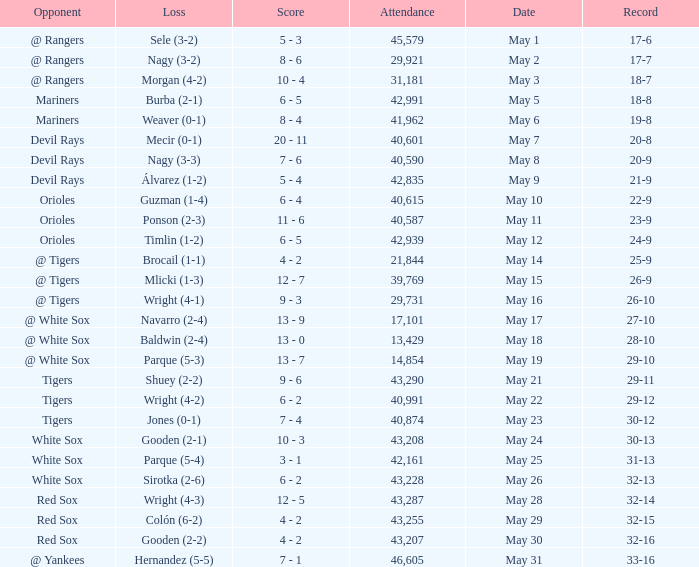Help me parse the entirety of this table. {'header': ['Opponent', 'Loss', 'Score', 'Attendance', 'Date', 'Record'], 'rows': [['@ Rangers', 'Sele (3-2)', '5 - 3', '45,579', 'May 1', '17-6'], ['@ Rangers', 'Nagy (3-2)', '8 - 6', '29,921', 'May 2', '17-7'], ['@ Rangers', 'Morgan (4-2)', '10 - 4', '31,181', 'May 3', '18-7'], ['Mariners', 'Burba (2-1)', '6 - 5', '42,991', 'May 5', '18-8'], ['Mariners', 'Weaver (0-1)', '8 - 4', '41,962', 'May 6', '19-8'], ['Devil Rays', 'Mecir (0-1)', '20 - 11', '40,601', 'May 7', '20-8'], ['Devil Rays', 'Nagy (3-3)', '7 - 6', '40,590', 'May 8', '20-9'], ['Devil Rays', 'Álvarez (1-2)', '5 - 4', '42,835', 'May 9', '21-9'], ['Orioles', 'Guzman (1-4)', '6 - 4', '40,615', 'May 10', '22-9'], ['Orioles', 'Ponson (2-3)', '11 - 6', '40,587', 'May 11', '23-9'], ['Orioles', 'Timlin (1-2)', '6 - 5', '42,939', 'May 12', '24-9'], ['@ Tigers', 'Brocail (1-1)', '4 - 2', '21,844', 'May 14', '25-9'], ['@ Tigers', 'Mlicki (1-3)', '12 - 7', '39,769', 'May 15', '26-9'], ['@ Tigers', 'Wright (4-1)', '9 - 3', '29,731', 'May 16', '26-10'], ['@ White Sox', 'Navarro (2-4)', '13 - 9', '17,101', 'May 17', '27-10'], ['@ White Sox', 'Baldwin (2-4)', '13 - 0', '13,429', 'May 18', '28-10'], ['@ White Sox', 'Parque (5-3)', '13 - 7', '14,854', 'May 19', '29-10'], ['Tigers', 'Shuey (2-2)', '9 - 6', '43,290', 'May 21', '29-11'], ['Tigers', 'Wright (4-2)', '6 - 2', '40,991', 'May 22', '29-12'], ['Tigers', 'Jones (0-1)', '7 - 4', '40,874', 'May 23', '30-12'], ['White Sox', 'Gooden (2-1)', '10 - 3', '43,208', 'May 24', '30-13'], ['White Sox', 'Parque (5-4)', '3 - 1', '42,161', 'May 25', '31-13'], ['White Sox', 'Sirotka (2-6)', '6 - 2', '43,228', 'May 26', '32-13'], ['Red Sox', 'Wright (4-3)', '12 - 5', '43,287', 'May 28', '32-14'], ['Red Sox', 'Colón (6-2)', '4 - 2', '43,255', 'May 29', '32-15'], ['Red Sox', 'Gooden (2-2)', '4 - 2', '43,207', 'May 30', '32-16'], ['@ Yankees', 'Hernandez (5-5)', '7 - 1', '46,605', 'May 31', '33-16']]} What loss has 26-9 as a loss? Mlicki (1-3). 